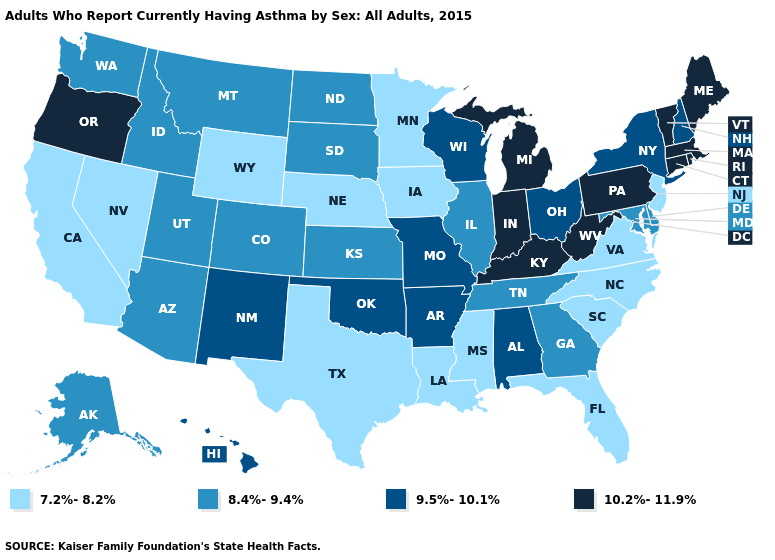What is the highest value in the USA?
Short answer required. 10.2%-11.9%. What is the value of South Carolina?
Concise answer only. 7.2%-8.2%. Does the map have missing data?
Answer briefly. No. Name the states that have a value in the range 7.2%-8.2%?
Quick response, please. California, Florida, Iowa, Louisiana, Minnesota, Mississippi, Nebraska, Nevada, New Jersey, North Carolina, South Carolina, Texas, Virginia, Wyoming. What is the value of Minnesota?
Short answer required. 7.2%-8.2%. What is the highest value in the USA?
Short answer required. 10.2%-11.9%. Name the states that have a value in the range 10.2%-11.9%?
Write a very short answer. Connecticut, Indiana, Kentucky, Maine, Massachusetts, Michigan, Oregon, Pennsylvania, Rhode Island, Vermont, West Virginia. Is the legend a continuous bar?
Write a very short answer. No. Name the states that have a value in the range 7.2%-8.2%?
Keep it brief. California, Florida, Iowa, Louisiana, Minnesota, Mississippi, Nebraska, Nevada, New Jersey, North Carolina, South Carolina, Texas, Virginia, Wyoming. Which states have the lowest value in the USA?
Concise answer only. California, Florida, Iowa, Louisiana, Minnesota, Mississippi, Nebraska, Nevada, New Jersey, North Carolina, South Carolina, Texas, Virginia, Wyoming. What is the highest value in the South ?
Quick response, please. 10.2%-11.9%. Name the states that have a value in the range 9.5%-10.1%?
Short answer required. Alabama, Arkansas, Hawaii, Missouri, New Hampshire, New Mexico, New York, Ohio, Oklahoma, Wisconsin. Name the states that have a value in the range 8.4%-9.4%?
Short answer required. Alaska, Arizona, Colorado, Delaware, Georgia, Idaho, Illinois, Kansas, Maryland, Montana, North Dakota, South Dakota, Tennessee, Utah, Washington. What is the value of Washington?
Quick response, please. 8.4%-9.4%. Which states have the highest value in the USA?
Be succinct. Connecticut, Indiana, Kentucky, Maine, Massachusetts, Michigan, Oregon, Pennsylvania, Rhode Island, Vermont, West Virginia. 